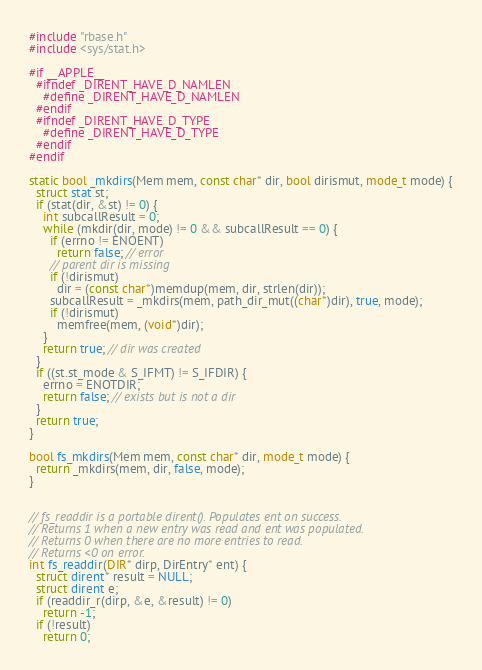<code> <loc_0><loc_0><loc_500><loc_500><_C_>#include "rbase.h"
#include <sys/stat.h>

#if __APPLE__
  #ifndef _DIRENT_HAVE_D_NAMLEN
    #define _DIRENT_HAVE_D_NAMLEN
  #endif
  #ifndef _DIRENT_HAVE_D_TYPE
    #define _DIRENT_HAVE_D_TYPE
  #endif
#endif

static bool _mkdirs(Mem mem, const char* dir, bool dirismut, mode_t mode) {
  struct stat st;
  if (stat(dir, &st) != 0) {
    int subcallResult = 0;
    while (mkdir(dir, mode) != 0 && subcallResult == 0) {
      if (errno != ENOENT)
        return false; // error
      // parent dir is missing
      if (!dirismut)
        dir = (const char*)memdup(mem, dir, strlen(dir));
      subcallResult = _mkdirs(mem, path_dir_mut((char*)dir), true, mode);
      if (!dirismut)
        memfree(mem, (void*)dir);
    }
    return true; // dir was created
  }
  if ((st.st_mode & S_IFMT) != S_IFDIR) {
    errno = ENOTDIR;
    return false; // exists but is not a dir
  }
  return true;
}

bool fs_mkdirs(Mem mem, const char* dir, mode_t mode) {
  return _mkdirs(mem, dir, false, mode);
}


// fs_readdir is a portable dirent(). Populates ent on success.
// Returns 1 when a new entry was read and ent was populated.
// Returns 0 when there are no more entries to read.
// Returns <0 on error.
int fs_readdir(DIR* dirp, DirEntry* ent) {
  struct dirent* result = NULL;
  struct dirent e;
  if (readdir_r(dirp, &e, &result) != 0)
    return -1;
  if (!result)
    return 0;</code> 